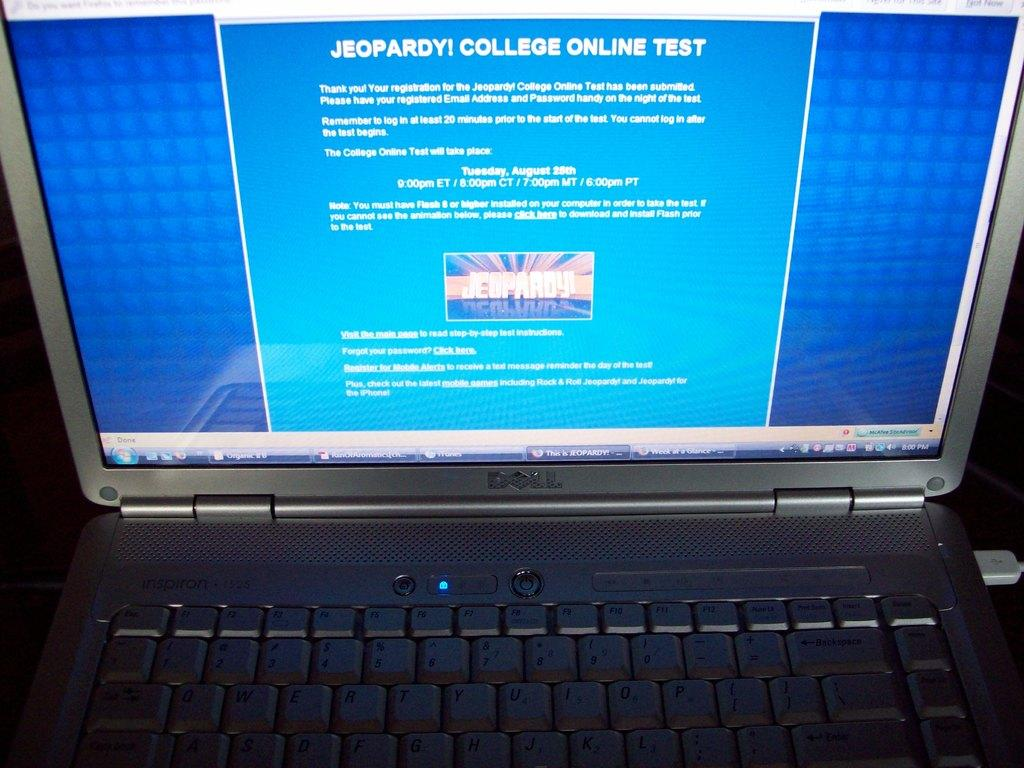<image>
Share a concise interpretation of the image provided. An online Jeopardy! College Test on a Dell laptop. 